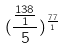<formula> <loc_0><loc_0><loc_500><loc_500>( \frac { \frac { 1 3 8 } { 1 } } { 5 } ) ^ { \frac { 7 7 } { 1 } }</formula> 